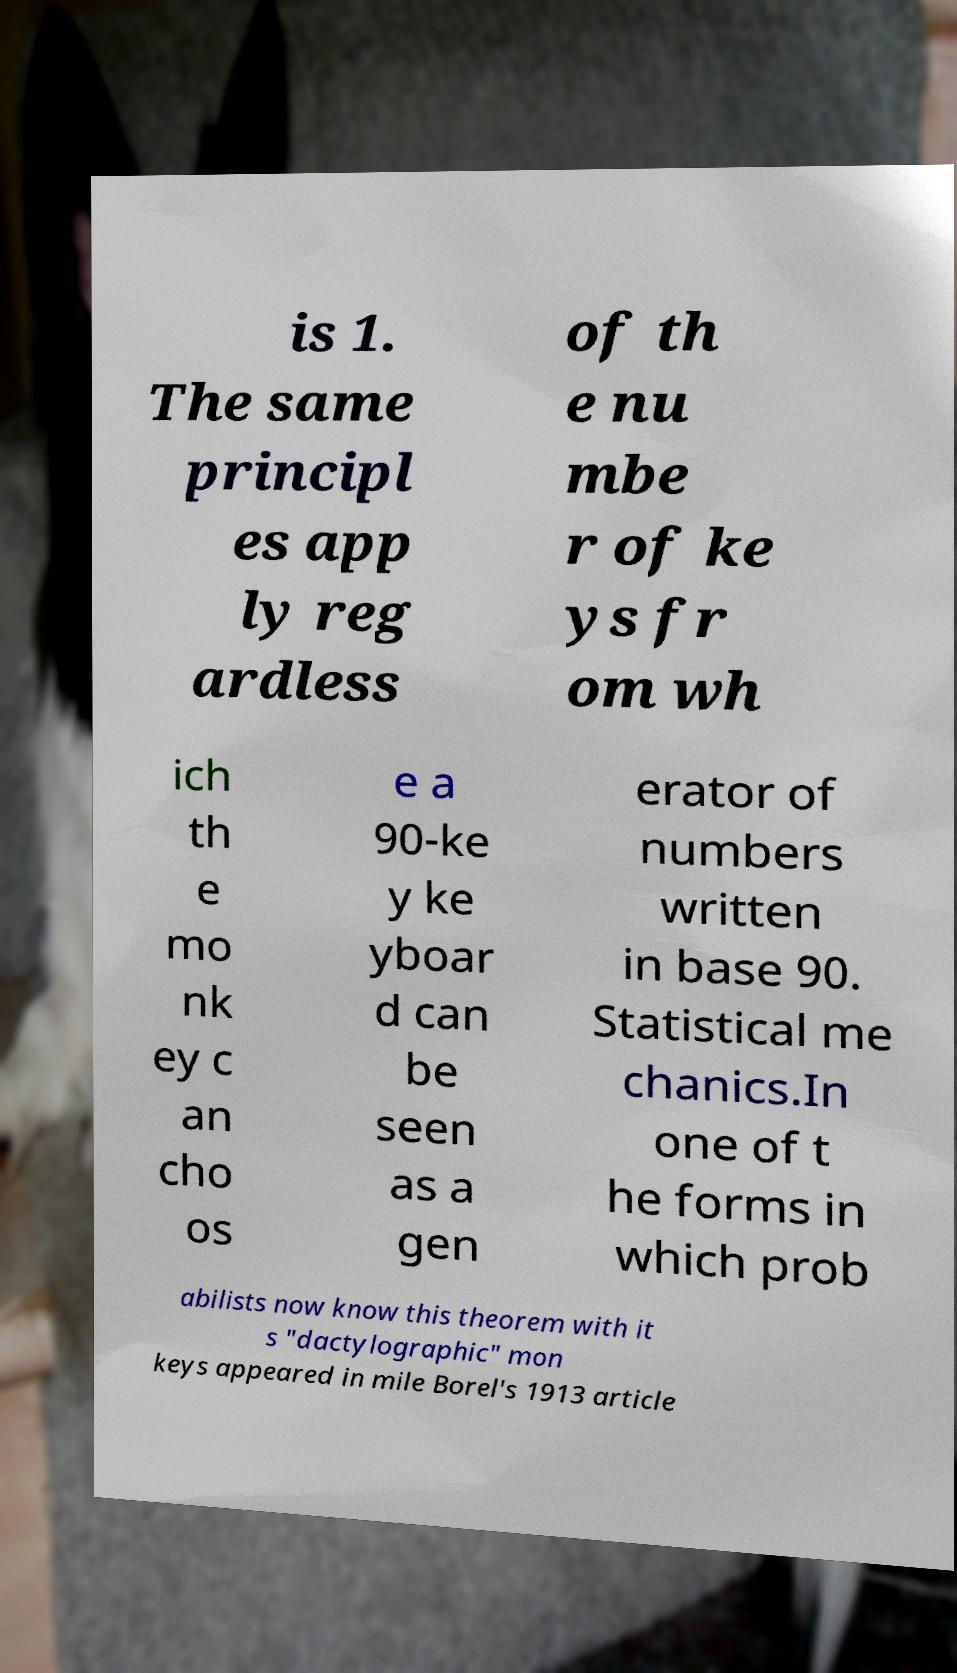For documentation purposes, I need the text within this image transcribed. Could you provide that? is 1. The same principl es app ly reg ardless of th e nu mbe r of ke ys fr om wh ich th e mo nk ey c an cho os e a 90-ke y ke yboar d can be seen as a gen erator of numbers written in base 90. Statistical me chanics.In one of t he forms in which prob abilists now know this theorem with it s "dactylographic" mon keys appeared in mile Borel's 1913 article 